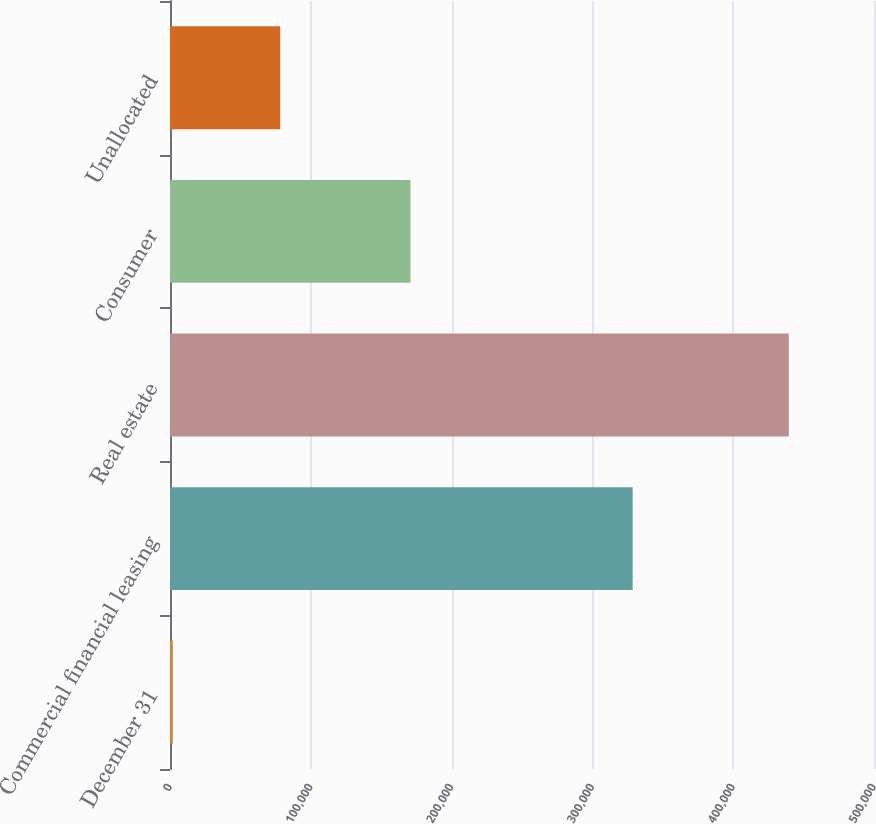Convert chart to OTSL. <chart><loc_0><loc_0><loc_500><loc_500><bar_chart><fcel>December 31<fcel>Commercial financial leasing<fcel>Real estate<fcel>Consumer<fcel>Unallocated<nl><fcel>2017<fcel>328599<fcel>439490<fcel>170809<fcel>78300<nl></chart> 